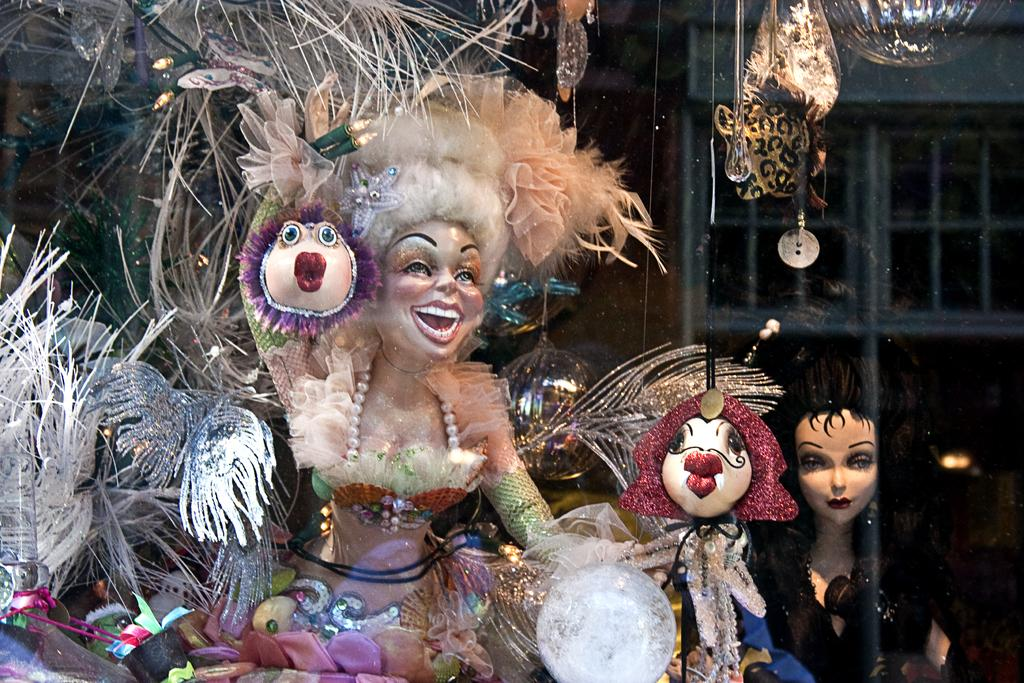What types of objects can be seen in the image? There are decorative objects in the image. Are there any sources of illumination visible? Yes, there are lights in the image. What is the purpose of the stand in the image? The stand is likely used to hold or display the decorative objects. What architectural feature is present in the image? There is a window in the image. What type of sand can be seen on the floor in the image? There is no sand present in the image; it features decorative objects, lights, a stand, and a window. 